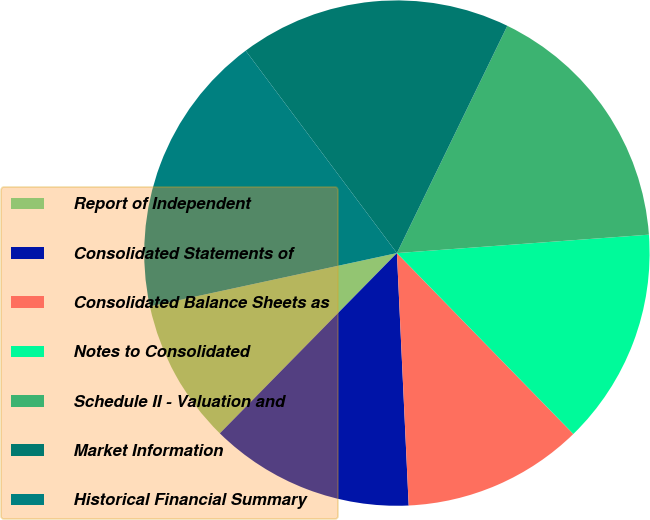Convert chart to OTSL. <chart><loc_0><loc_0><loc_500><loc_500><pie_chart><fcel>Report of Independent<fcel>Consolidated Statements of<fcel>Consolidated Balance Sheets as<fcel>Notes to Consolidated<fcel>Schedule II - Valuation and<fcel>Market Information<fcel>Historical Financial Summary<nl><fcel>9.26%<fcel>13.1%<fcel>11.56%<fcel>13.86%<fcel>16.64%<fcel>17.41%<fcel>18.17%<nl></chart> 